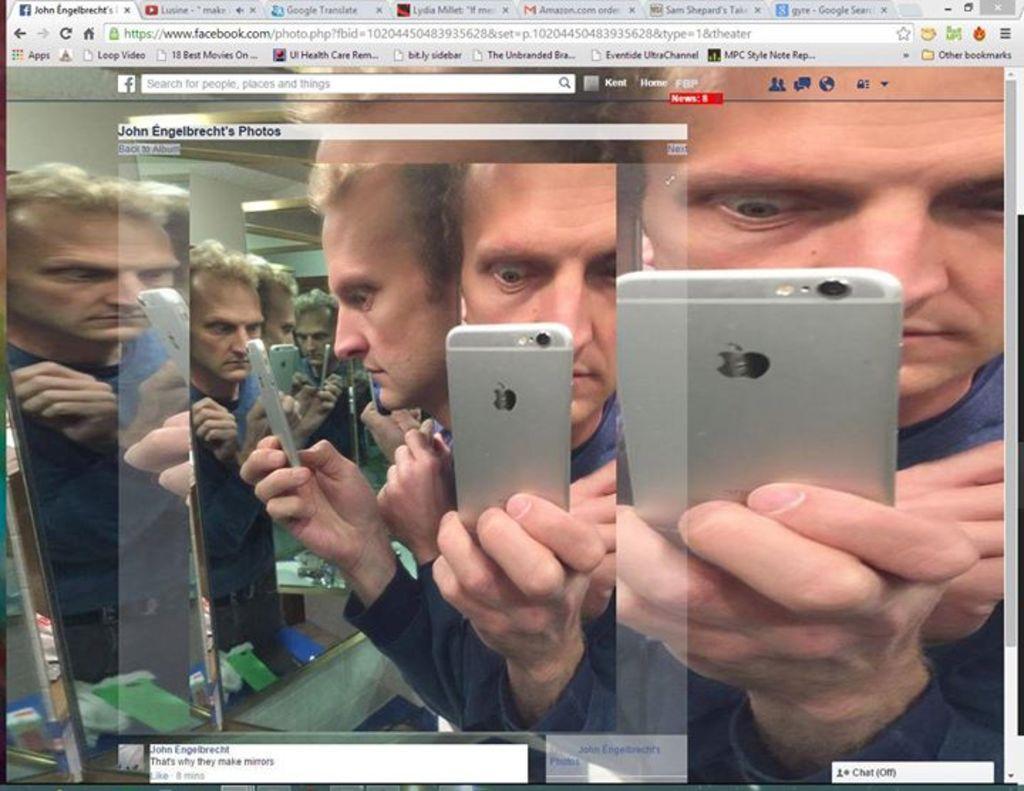Please provide a concise description of this image. In this picture we can see a screen. On the screen there is a person who is holding a mobile with his hand. 